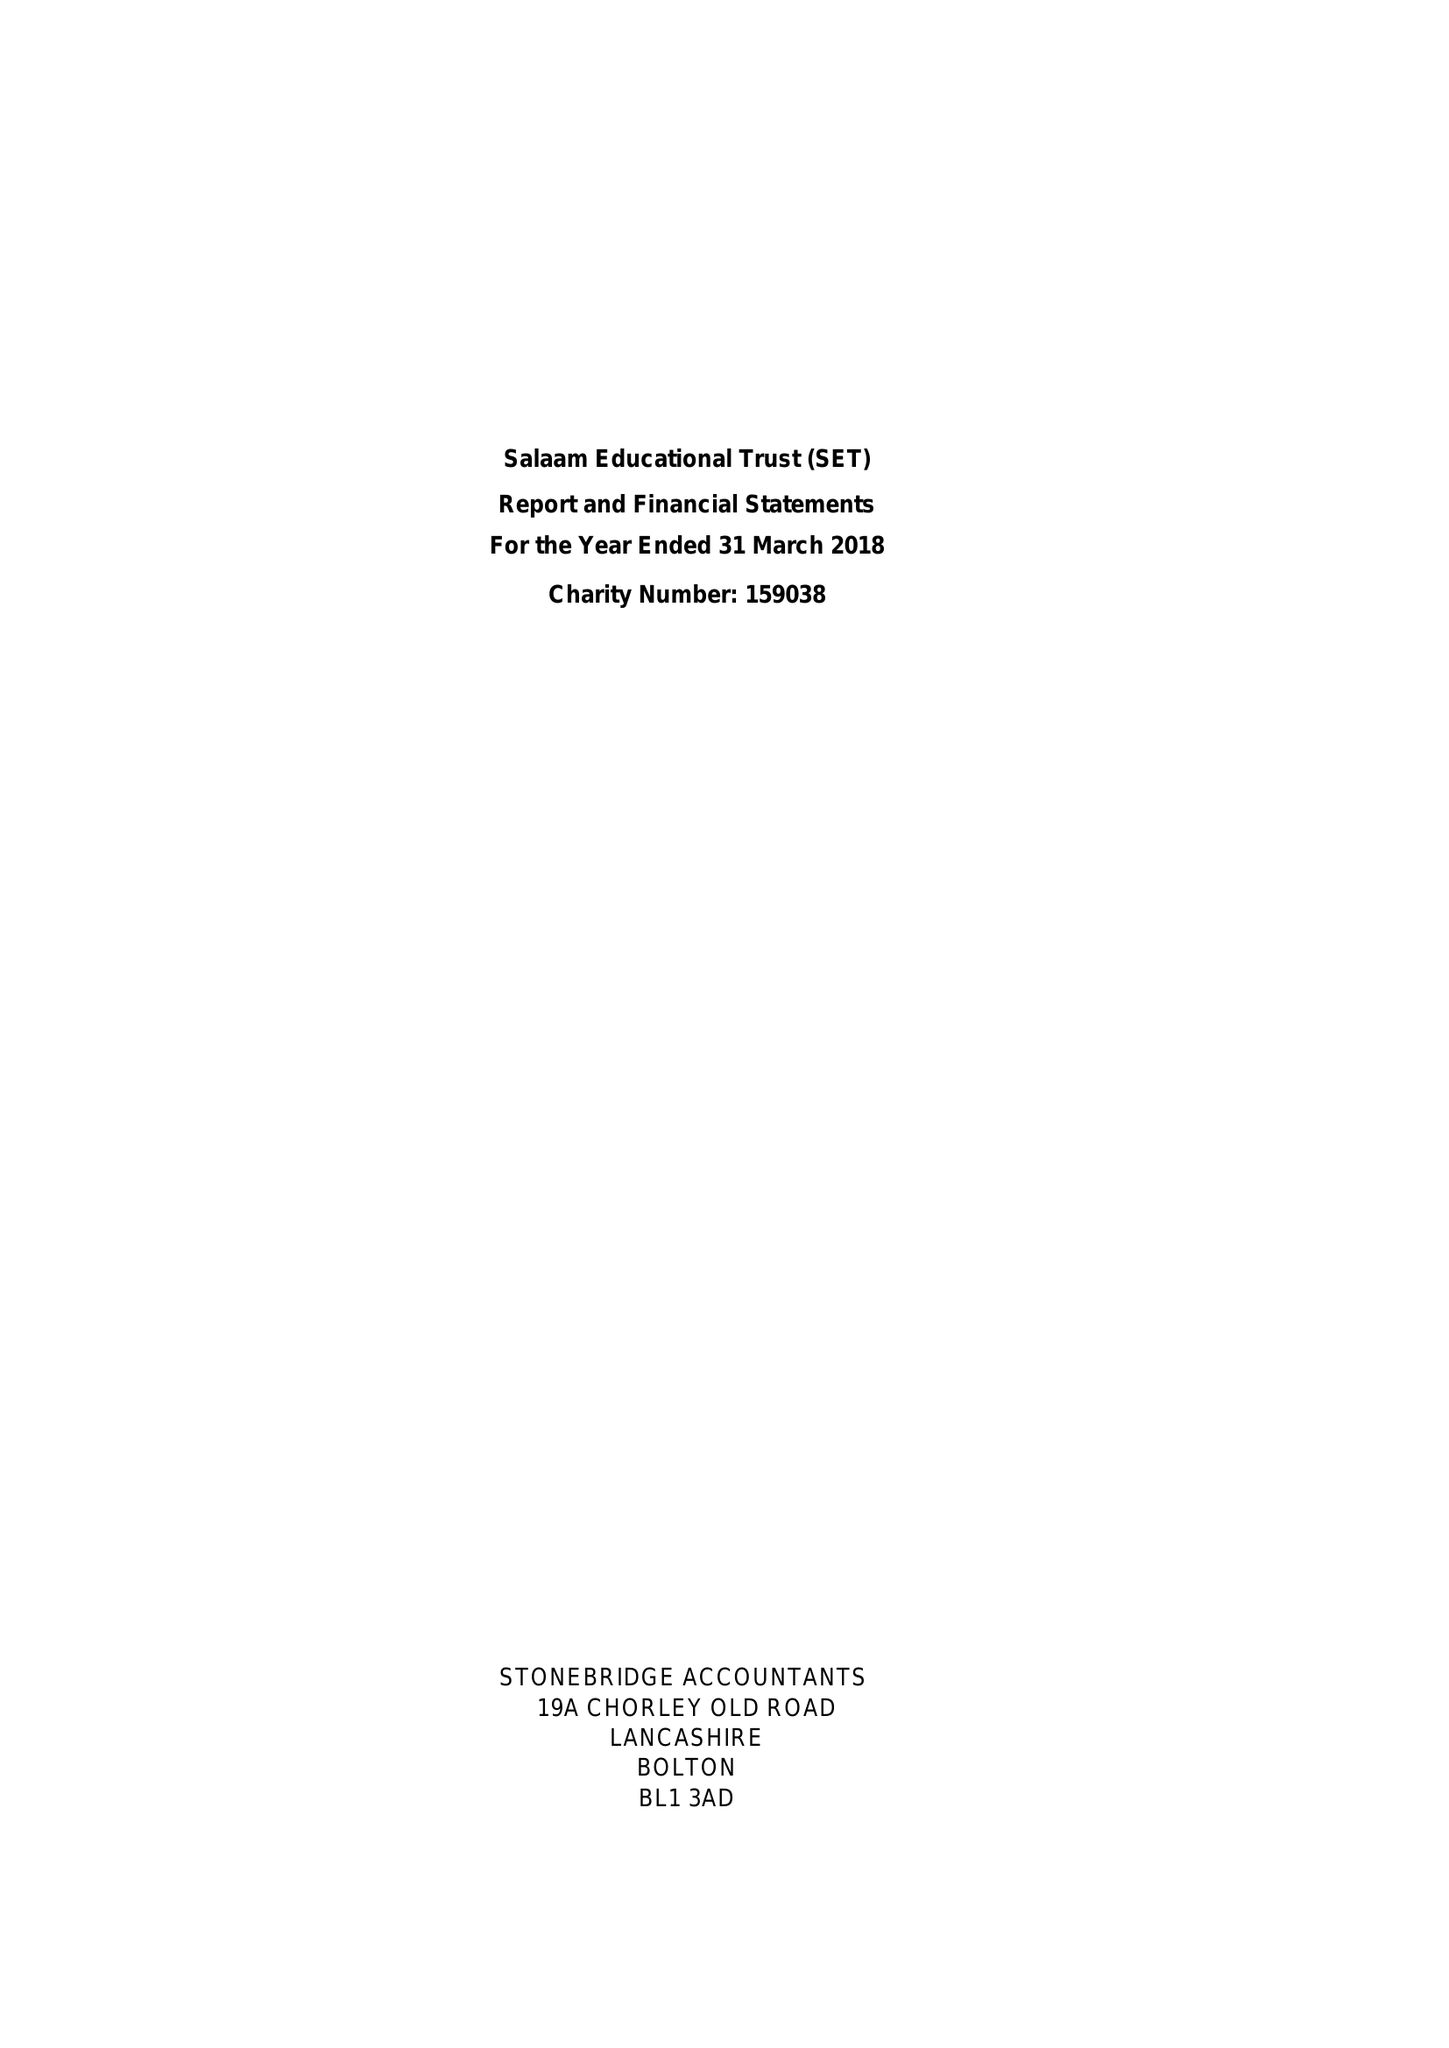What is the value for the address__postcode?
Answer the question using a single word or phrase. PR2 8EA 